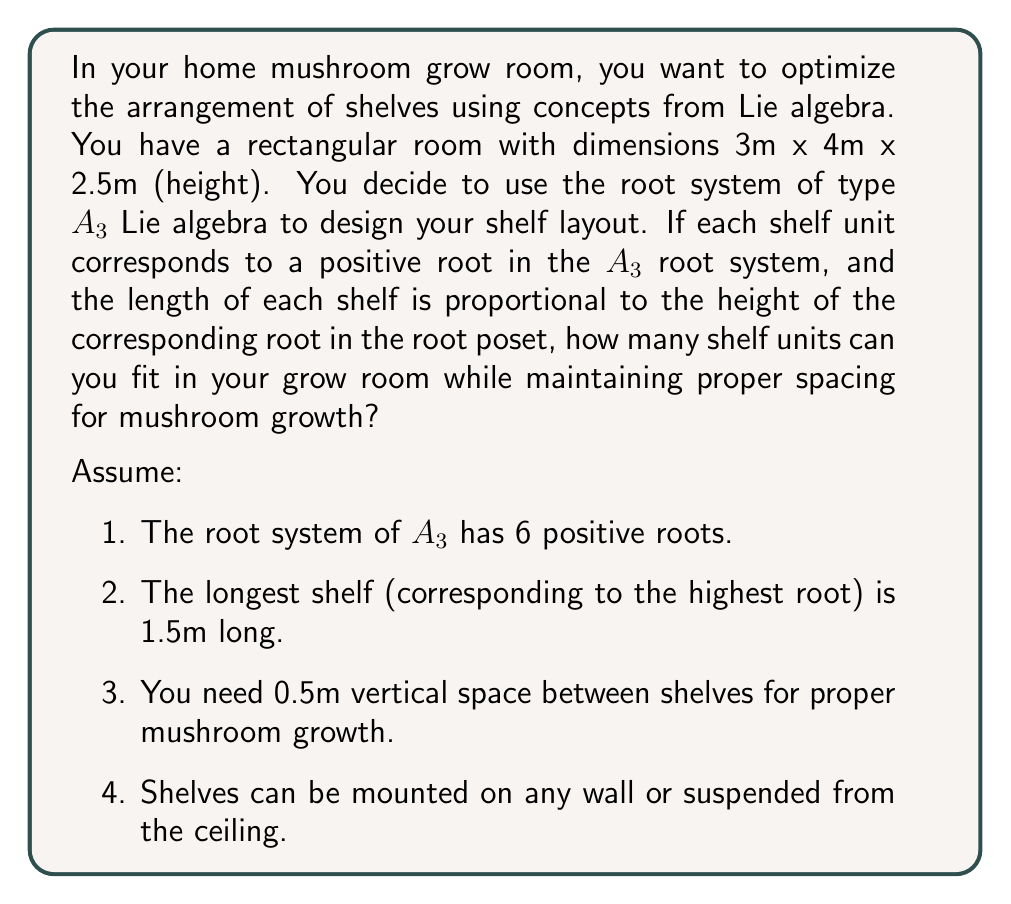Solve this math problem. To solve this problem, we need to understand the root system of $A_3$ Lie algebra and apply it to our mushroom grow room setup.

1. The positive roots of $A_3$ are:
   $\alpha_1, \alpha_2, \alpha_3$ (simple roots)
   $\alpha_1 + \alpha_2, \alpha_2 + \alpha_3$ (height 2 roots)
   $\alpha_1 + \alpha_2 + \alpha_3$ (highest root)

2. The heights of these roots in the root poset are 1, 1, 1, 2, 2, and 3 respectively.

3. If the longest shelf (highest root) is 1.5m, we can calculate the lengths of the other shelves:
   - Height 1 roots: $1.5m \times (1/3) = 0.5m$
   - Height 2 roots: $1.5m \times (2/3) = 1m$
   - Height 3 root: $1.5m$

4. Available wall space:
   - Two 3m x 2.5m walls
   - Two 4m x 2.5m walls
   - One 3m x 4m ceiling

5. Shelf arrangement:
   - We can fit 5 columns of shelves with 0.5m spacing between them on the 3m walls
   - We can fit 7 columns of shelves with 0.5m spacing between them on the 4m walls
   - We can fit 4 rows of shelves with 0.5m spacing between them on the 2.5m height

6. Shelf placement:
   - Place the 1.5m shelf on one 4m wall
   - Place two 1m shelves on the other 4m wall
   - Place three 0.5m shelves on each 3m wall
   - Suspend any remaining shelves from the ceiling

7. Total shelf units:
   - 1 x 1.5m shelf
   - 2 x 1m shelves
   - 6 x 0.5m shelves
   
This arrangement uses all 6 positive roots of the $A_3$ root system while maintaining proper spacing for mushroom growth.
Answer: The optimal arrangement based on the $A_3$ root system allows for 9 shelf units in the mushroom grow room. 